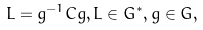<formula> <loc_0><loc_0><loc_500><loc_500>L = g ^ { - 1 } C g , L \in G ^ { * } , g \in G ,</formula> 